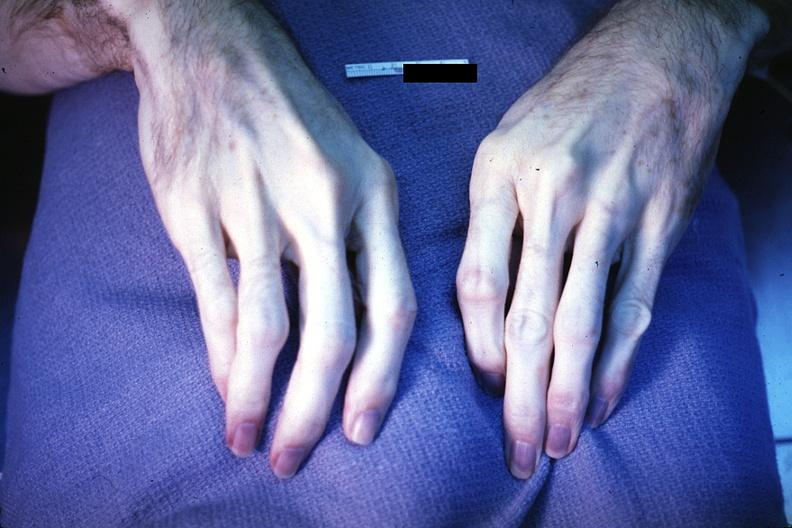re extremities present?
Answer the question using a single word or phrase. Yes 